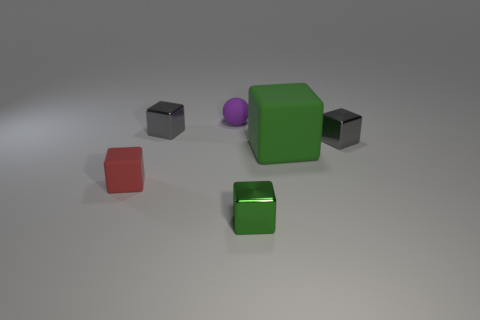The metallic block that is the same color as the big thing is what size?
Your answer should be very brief. Small. What shape is the tiny thing that is the same color as the big cube?
Provide a succinct answer. Cube. How many other things are the same material as the purple thing?
Provide a short and direct response. 2. How big is the green rubber object?
Your answer should be very brief. Large. Is there another tiny red matte thing of the same shape as the tiny red object?
Provide a succinct answer. No. How many things are either tiny brown metallic spheres or cubes that are on the right side of the big green thing?
Provide a short and direct response. 1. What is the color of the metal cube that is in front of the large rubber block?
Give a very brief answer. Green. Do the purple thing on the right side of the red matte object and the gray metal block to the left of the tiny matte sphere have the same size?
Your answer should be very brief. Yes. Are there any gray cubes of the same size as the purple ball?
Your response must be concise. Yes. There is a gray shiny block that is left of the tiny purple object; how many metallic blocks are right of it?
Keep it short and to the point. 2. 